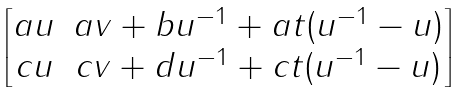Convert formula to latex. <formula><loc_0><loc_0><loc_500><loc_500>\begin{bmatrix} a u & a v + b u ^ { - 1 } + a t ( u ^ { - 1 } - u ) \\ c u & c v + d u ^ { - 1 } + c t ( u ^ { - 1 } - u ) \end{bmatrix}</formula> 